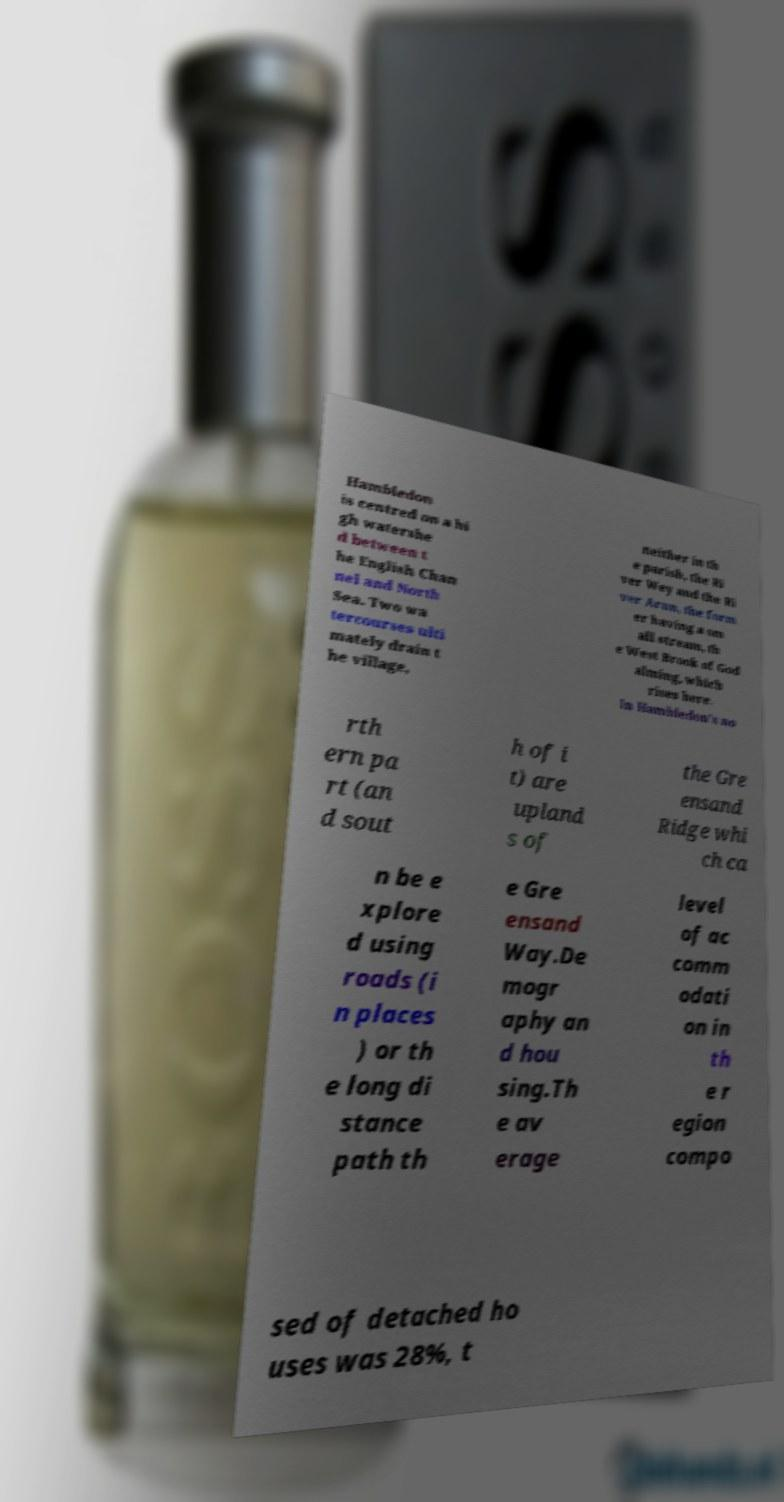Please read and relay the text visible in this image. What does it say? Hambledon is centred on a hi gh watershe d between t he English Chan nel and North Sea. Two wa tercourses ulti mately drain t he village, neither in th e parish, the Ri ver Wey and the Ri ver Arun, the form er having a sm all stream, th e West Brook of God alming, which rises here. In Hambledon's no rth ern pa rt (an d sout h of i t) are upland s of the Gre ensand Ridge whi ch ca n be e xplore d using roads (i n places ) or th e long di stance path th e Gre ensand Way.De mogr aphy an d hou sing.Th e av erage level of ac comm odati on in th e r egion compo sed of detached ho uses was 28%, t 